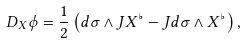Convert formula to latex. <formula><loc_0><loc_0><loc_500><loc_500>D _ { X } \phi = \frac { 1 } { 2 } \left ( d \sigma \wedge J X ^ { \flat } - J d \sigma \wedge X ^ { \flat } \right ) ,</formula> 